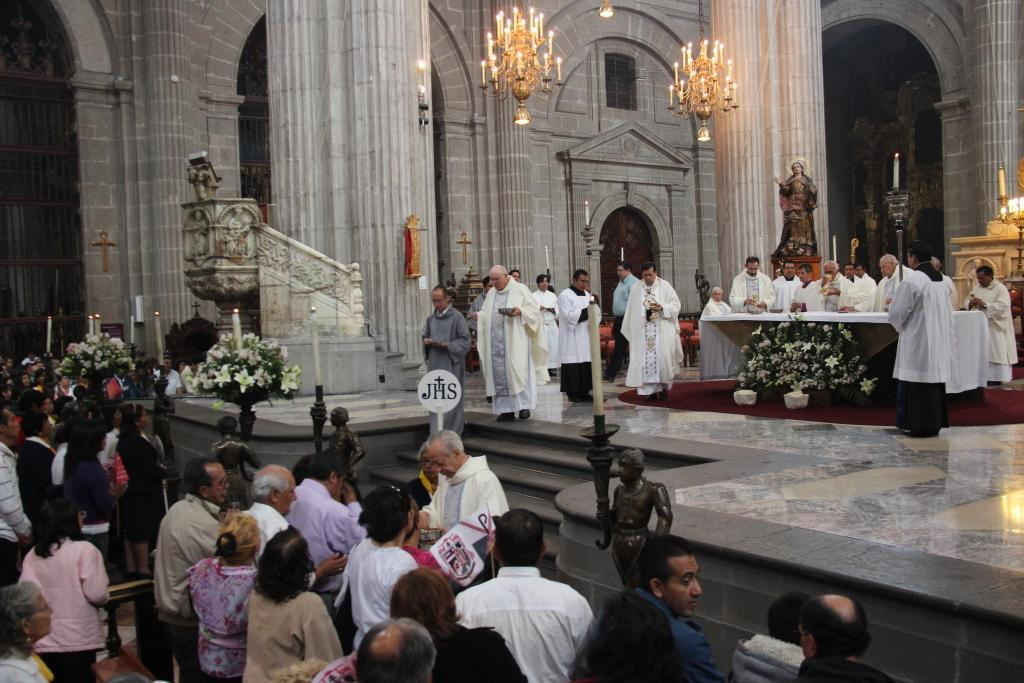How many people are in the group that is visible in the image? There is a group of people standing in the image, but the exact number cannot be determined from the provided facts. What type of lighting is present in the image? There are chandeliers and candles in the image, which provide lighting. What type of decorative objects can be seen in the image? There are sculptures in the image. What type of floral arrangement is present in the image? There are flowers in the image. What type of furniture is present in the image? There is a table in the image. What other items can be seen in the image? There are some other items in the image, but their specific nature cannot be determined from the provided facts. How does the group of people in the image plan to win the war? There is no mention of a war or any conflict in the image, so it is not possible to answer this question. What type of friction can be seen between the candles and the table in the image? There is no indication of friction between the candles and the table in the image, as they are likely stationary and not interacting with each other. 